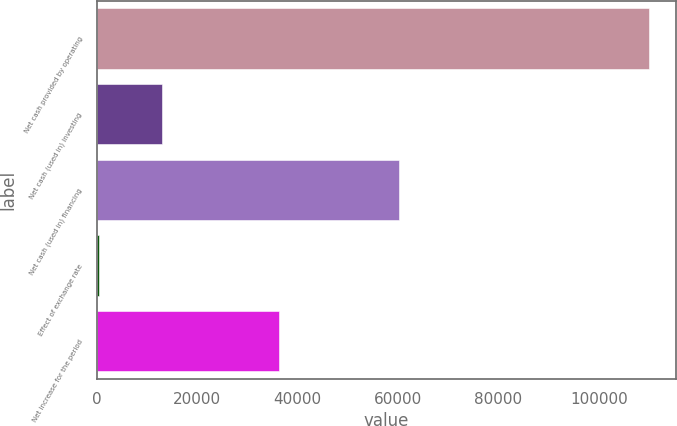Convert chart to OTSL. <chart><loc_0><loc_0><loc_500><loc_500><bar_chart><fcel>Net cash provided by operating<fcel>Net cash (used in) investing<fcel>Net cash (used in) financing<fcel>Effect of exchange rate<fcel>Net increase for the period<nl><fcel>109952<fcel>13025<fcel>60223<fcel>471<fcel>36233<nl></chart> 